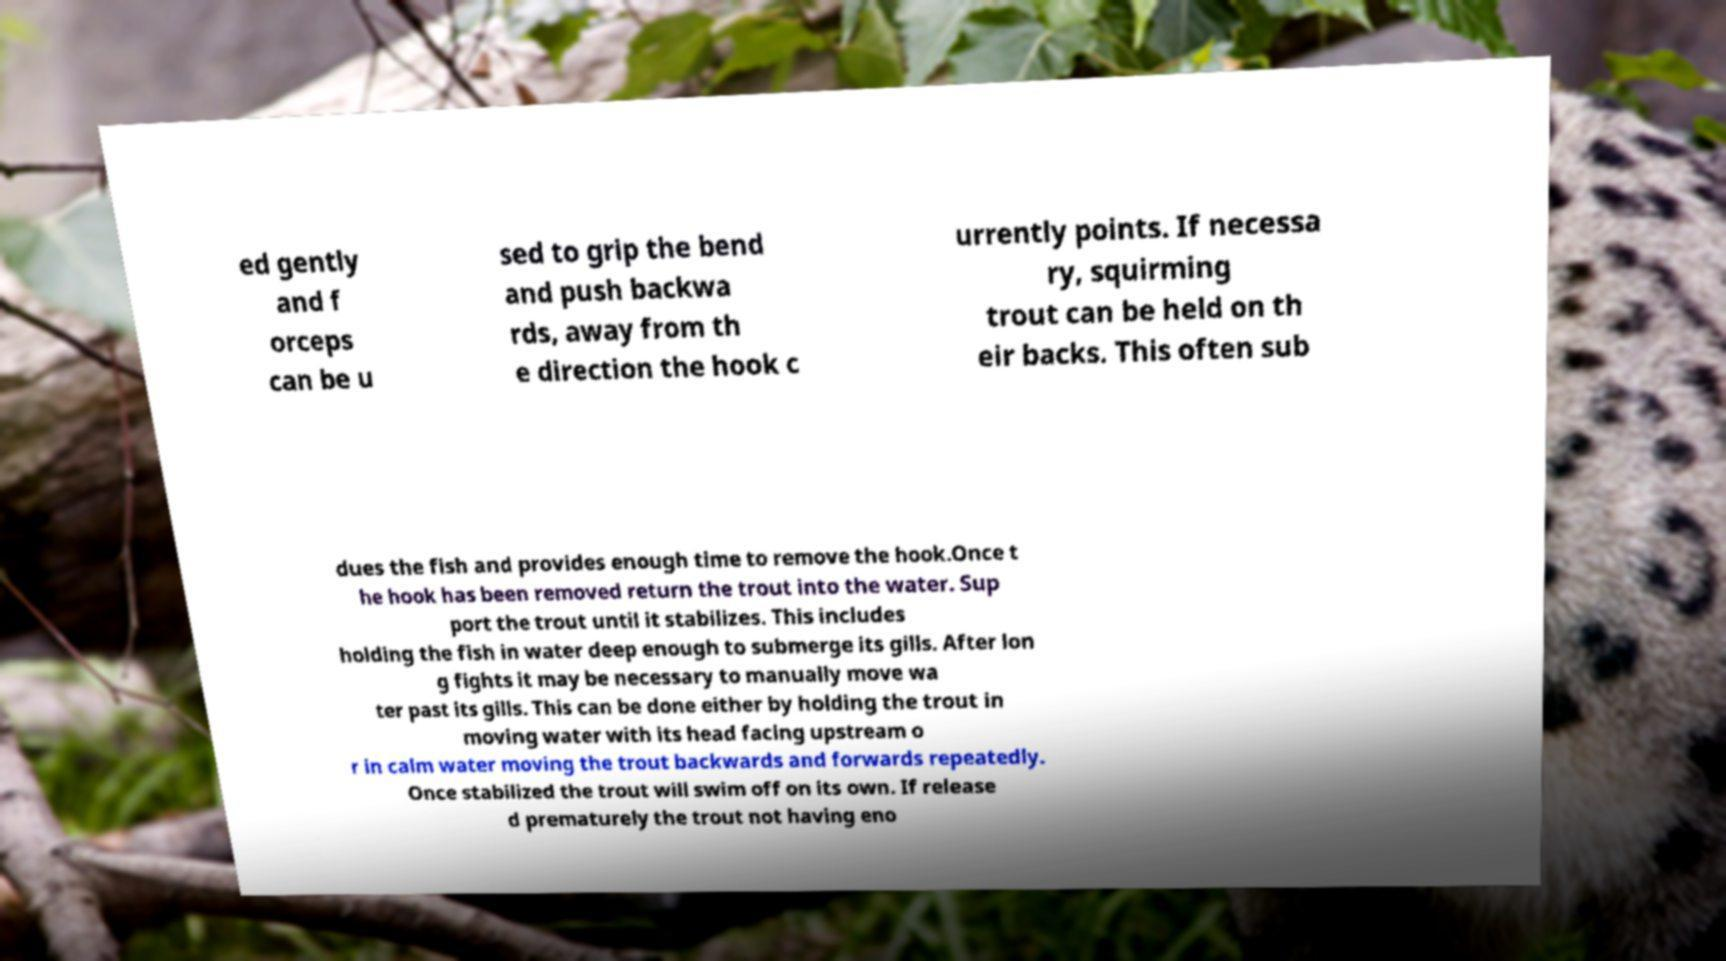What messages or text are displayed in this image? I need them in a readable, typed format. ed gently and f orceps can be u sed to grip the bend and push backwa rds, away from th e direction the hook c urrently points. If necessa ry, squirming trout can be held on th eir backs. This often sub dues the fish and provides enough time to remove the hook.Once t he hook has been removed return the trout into the water. Sup port the trout until it stabilizes. This includes holding the fish in water deep enough to submerge its gills. After lon g fights it may be necessary to manually move wa ter past its gills. This can be done either by holding the trout in moving water with its head facing upstream o r in calm water moving the trout backwards and forwards repeatedly. Once stabilized the trout will swim off on its own. If release d prematurely the trout not having eno 